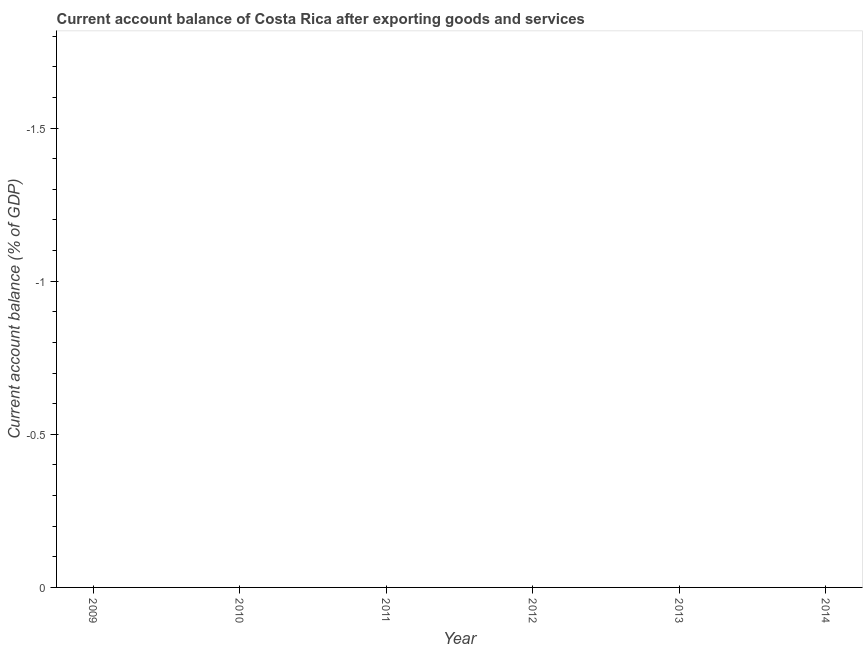Across all years, what is the minimum current account balance?
Offer a terse response. 0. What is the sum of the current account balance?
Your answer should be compact. 0. What is the median current account balance?
Provide a succinct answer. 0. How many dotlines are there?
Provide a succinct answer. 0. What is the difference between two consecutive major ticks on the Y-axis?
Offer a terse response. 0.5. Are the values on the major ticks of Y-axis written in scientific E-notation?
Ensure brevity in your answer.  No. Does the graph contain any zero values?
Offer a very short reply. Yes. Does the graph contain grids?
Provide a succinct answer. No. What is the title of the graph?
Your answer should be compact. Current account balance of Costa Rica after exporting goods and services. What is the label or title of the Y-axis?
Make the answer very short. Current account balance (% of GDP). What is the Current account balance (% of GDP) in 2009?
Give a very brief answer. 0. What is the Current account balance (% of GDP) in 2010?
Provide a succinct answer. 0. What is the Current account balance (% of GDP) in 2011?
Your response must be concise. 0. What is the Current account balance (% of GDP) in 2013?
Give a very brief answer. 0. 